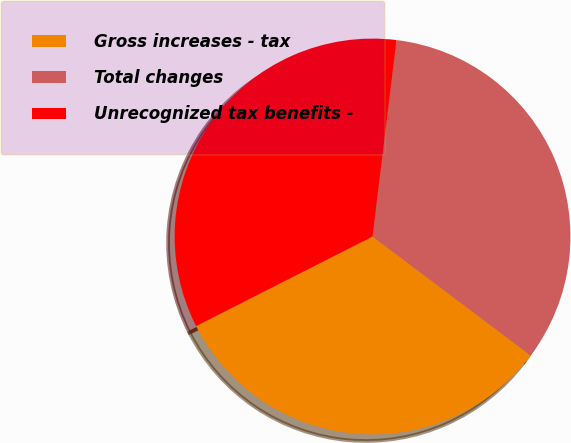Convert chart to OTSL. <chart><loc_0><loc_0><loc_500><loc_500><pie_chart><fcel>Gross increases - tax<fcel>Total changes<fcel>Unrecognized tax benefits -<nl><fcel>32.26%<fcel>33.33%<fcel>34.41%<nl></chart> 